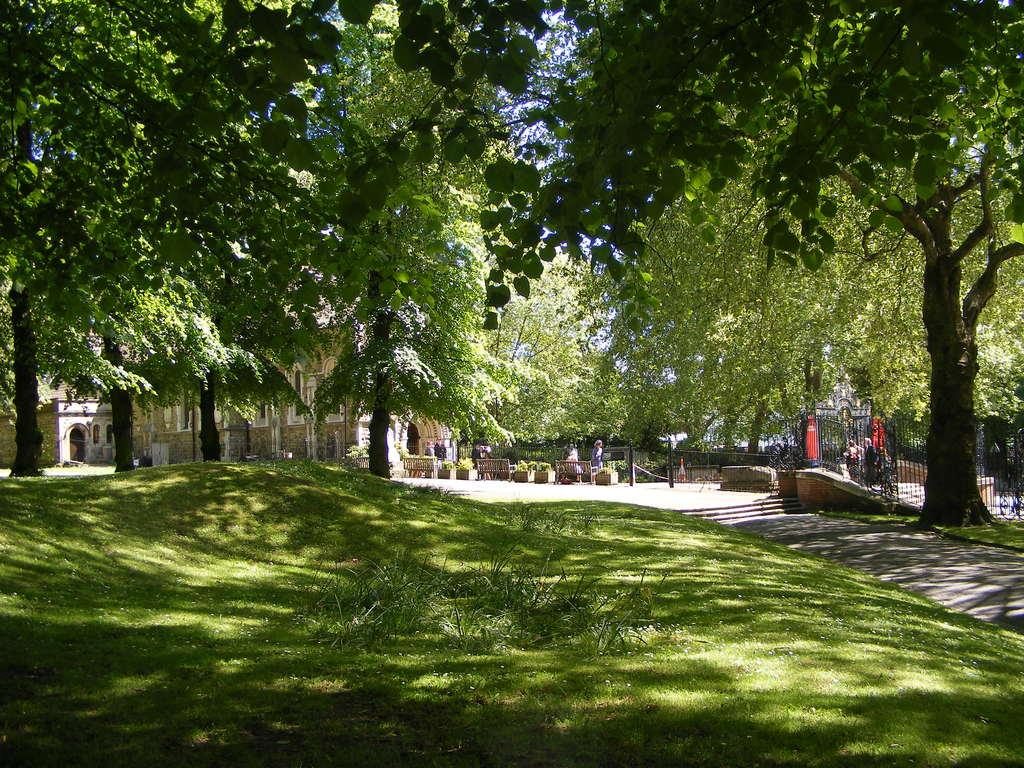What type of natural scenery is visible in the foreground of the image? There is green grass and trees in the foreground of the image. What can be seen in the background of the image? There are buildings and wooden benches in the background of the image. Are there any people visible in the image? Yes, there are a few persons visible in the background of the image. What type of station is depicted in the image? There is no station present in the image. Can you tell me how many donkeys are grazing in the green grass? There are no donkeys present in the image; it features green grass and trees. 